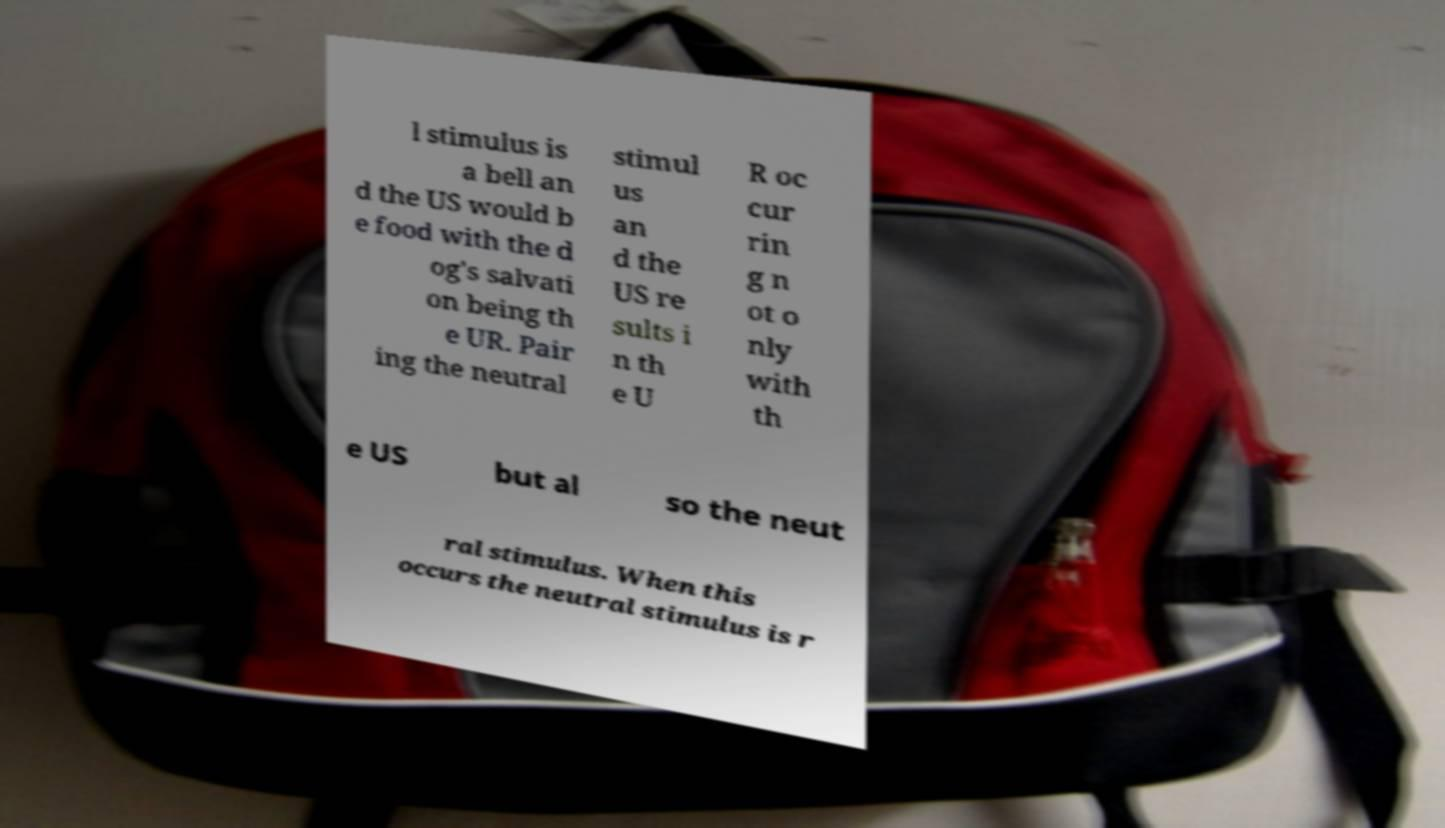What messages or text are displayed in this image? I need them in a readable, typed format. l stimulus is a bell an d the US would b e food with the d og's salvati on being th e UR. Pair ing the neutral stimul us an d the US re sults i n th e U R oc cur rin g n ot o nly with th e US but al so the neut ral stimulus. When this occurs the neutral stimulus is r 